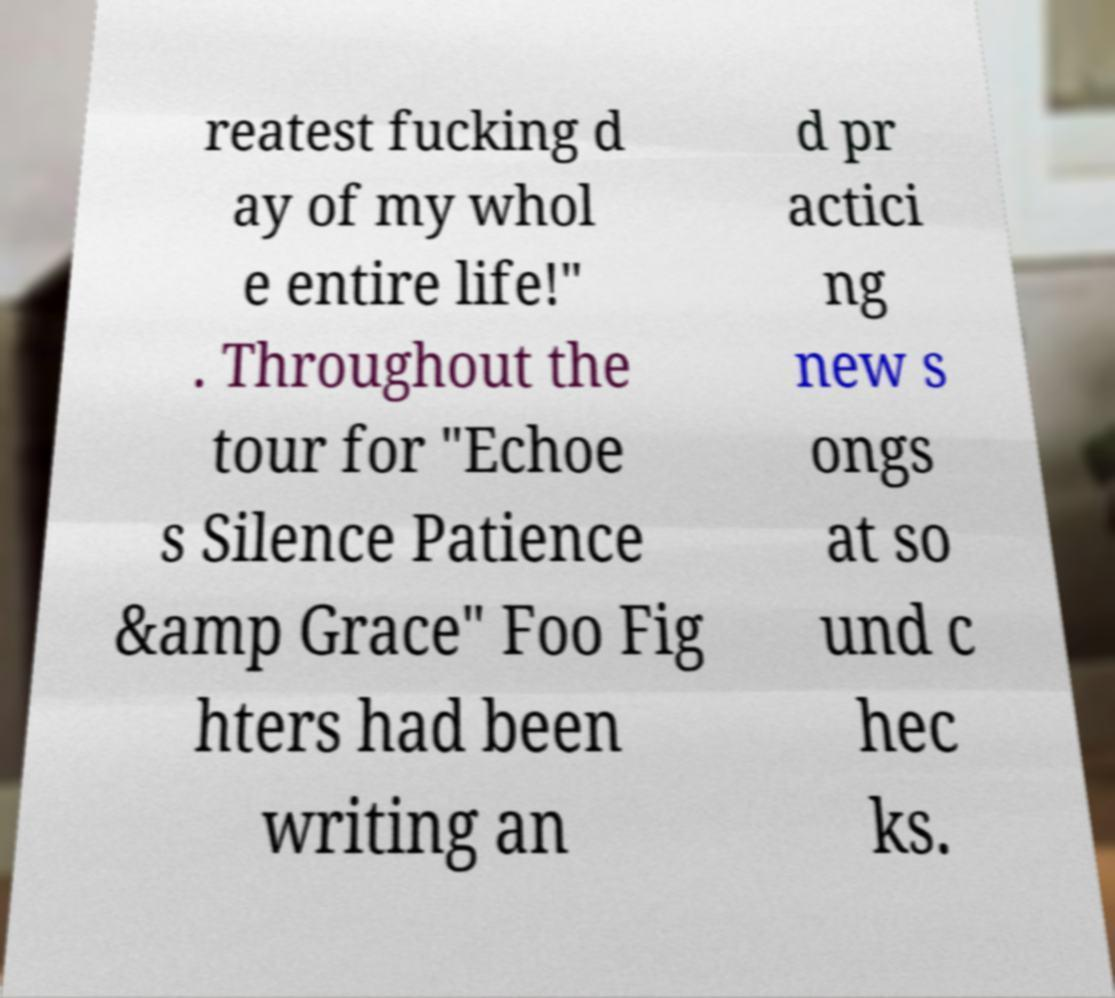What messages or text are displayed in this image? I need them in a readable, typed format. reatest fucking d ay of my whol e entire life!" . Throughout the tour for "Echoe s Silence Patience &amp Grace" Foo Fig hters had been writing an d pr actici ng new s ongs at so und c hec ks. 